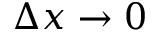<formula> <loc_0><loc_0><loc_500><loc_500>\Delta x \rightarrow 0</formula> 